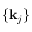<formula> <loc_0><loc_0><loc_500><loc_500>\{ k _ { j } \}</formula> 